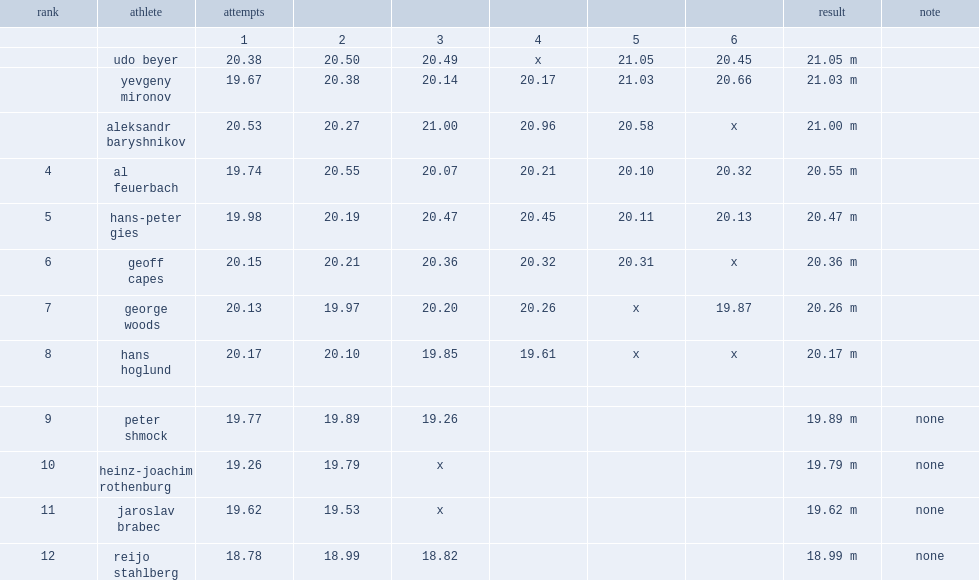How many meters was the first round leader aleksandr baryshnikov with? 20.53. 